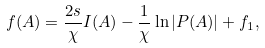<formula> <loc_0><loc_0><loc_500><loc_500>f ( A ) = \frac { 2 s } { \chi } I ( A ) - \frac { 1 } { \chi } \ln | P ( A ) | + f _ { 1 } ,</formula> 